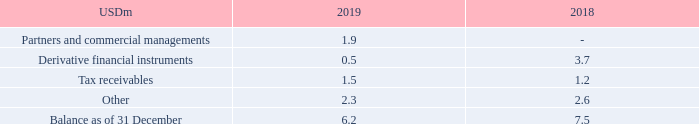NOTE 11 – OTHER RECEIVABLES
No significant other receivables are past due or credit impaired.
The carrying amount is a reasonable approximation of fair value due to the short-term nature of the receivables. Please refer to note 21 for further information on fair value hierarchies.
Why is the carrying amount a reasonable approximation of fair value? Due to the short-term nature of the receivables. What information does note 21 contain? Further information on fair value hierarchies. What are the components under Other Receivables in the table? Partners and commercial managements, derivative financial instruments, tax receivables, other. In which year was the amount of Other larger? 2.6>2.3
Answer: 2018. What was the change in the Balance as of 31 December from 2018 to 2019?
Answer scale should be: million. 6.2-7.5
Answer: -1.3. What was the percentage change in the Balance as of 31 December from 2018 to 2019?
Answer scale should be: percent. (6.2-7.5)/7.5
Answer: -17.33. 